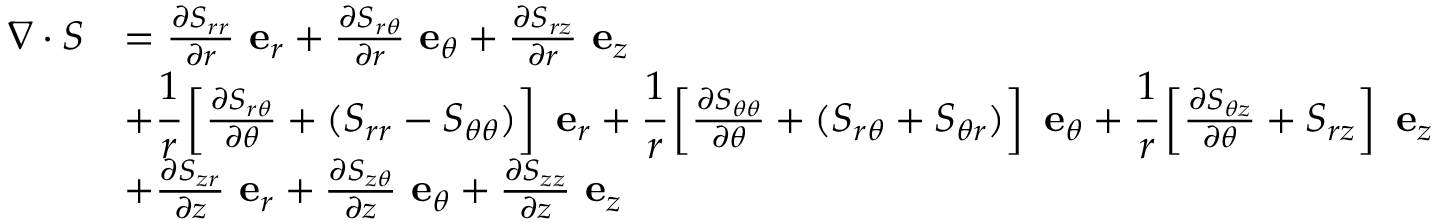<formula> <loc_0><loc_0><loc_500><loc_500>{ \begin{array} { r l } { { \nabla } \cdot { S } } & { = { \frac { \partial S _ { r r } } { \partial r } } e _ { r } + { \frac { \partial S _ { r \theta } } { \partial r } } e _ { \theta } + { \frac { \partial S _ { r z } } { \partial r } } e _ { z } } \\ & { + { \cfrac { 1 } { r } } \left [ { \frac { \partial S _ { r \theta } } { \partial \theta } } + ( S _ { r r } - S _ { \theta \theta } ) \right ] e _ { r } + { \cfrac { 1 } { r } } \left [ { \frac { \partial S _ { \theta \theta } } { \partial \theta } } + ( S _ { r \theta } + S _ { \theta r } ) \right ] e _ { \theta } + { \cfrac { 1 } { r } } \left [ { \frac { \partial S _ { \theta z } } { \partial \theta } } + S _ { r z } \right ] e _ { z } } \\ & { + { \frac { \partial S _ { z r } } { \partial z } } e _ { r } + { \frac { \partial S _ { z \theta } } { \partial z } } e _ { \theta } + { \frac { \partial S _ { z z } } { \partial z } } e _ { z } } \end{array} }</formula> 